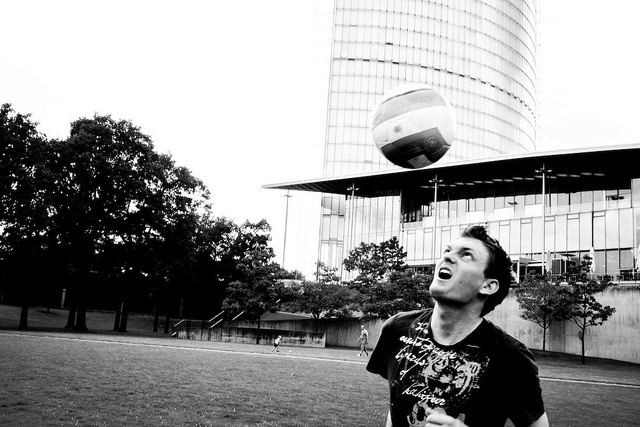Describe the objects in this image and their specific colors. I can see people in white, black, darkgray, lightgray, and gray tones, sports ball in white, black, gray, and darkgray tones, people in white, darkgray, gray, gainsboro, and black tones, and people in white, darkgray, lightgray, gray, and black tones in this image. 